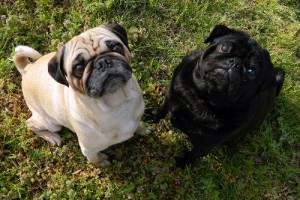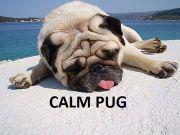The first image is the image on the left, the second image is the image on the right. Given the left and right images, does the statement "Two buff beige pugs with dark muzzles, at least one wearing a collar, are close together and face to face in the right image." hold true? Answer yes or no. No. 